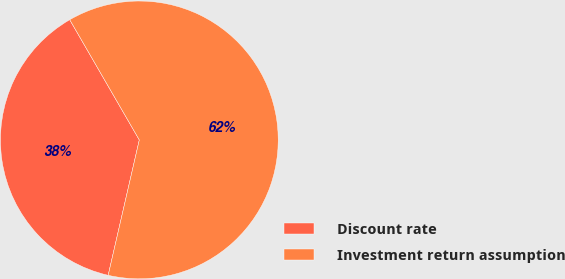Convert chart. <chart><loc_0><loc_0><loc_500><loc_500><pie_chart><fcel>Discount rate<fcel>Investment return assumption<nl><fcel>38.05%<fcel>61.95%<nl></chart> 